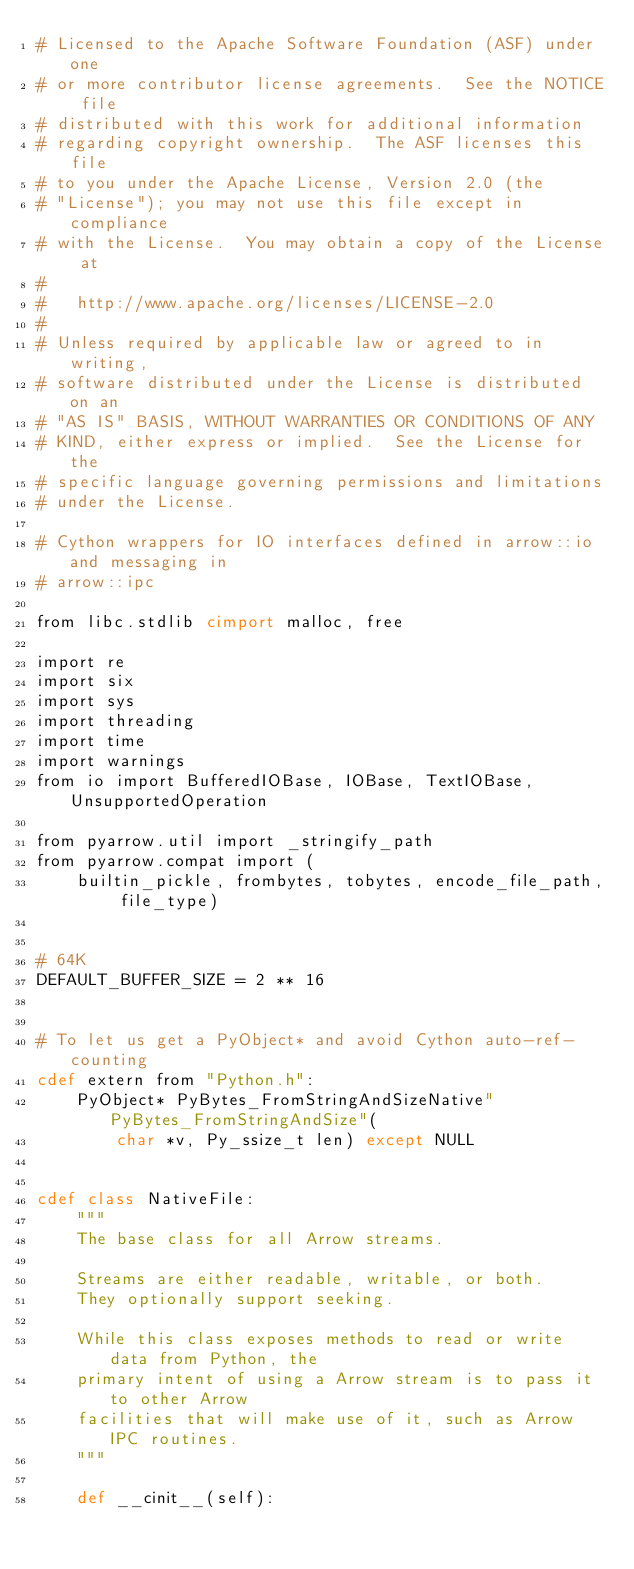Convert code to text. <code><loc_0><loc_0><loc_500><loc_500><_Cython_># Licensed to the Apache Software Foundation (ASF) under one
# or more contributor license agreements.  See the NOTICE file
# distributed with this work for additional information
# regarding copyright ownership.  The ASF licenses this file
# to you under the Apache License, Version 2.0 (the
# "License"); you may not use this file except in compliance
# with the License.  You may obtain a copy of the License at
#
#   http://www.apache.org/licenses/LICENSE-2.0
#
# Unless required by applicable law or agreed to in writing,
# software distributed under the License is distributed on an
# "AS IS" BASIS, WITHOUT WARRANTIES OR CONDITIONS OF ANY
# KIND, either express or implied.  See the License for the
# specific language governing permissions and limitations
# under the License.

# Cython wrappers for IO interfaces defined in arrow::io and messaging in
# arrow::ipc

from libc.stdlib cimport malloc, free

import re
import six
import sys
import threading
import time
import warnings
from io import BufferedIOBase, IOBase, TextIOBase, UnsupportedOperation

from pyarrow.util import _stringify_path
from pyarrow.compat import (
    builtin_pickle, frombytes, tobytes, encode_file_path, file_type)


# 64K
DEFAULT_BUFFER_SIZE = 2 ** 16


# To let us get a PyObject* and avoid Cython auto-ref-counting
cdef extern from "Python.h":
    PyObject* PyBytes_FromStringAndSizeNative" PyBytes_FromStringAndSize"(
        char *v, Py_ssize_t len) except NULL


cdef class NativeFile:
    """
    The base class for all Arrow streams.

    Streams are either readable, writable, or both.
    They optionally support seeking.

    While this class exposes methods to read or write data from Python, the
    primary intent of using a Arrow stream is to pass it to other Arrow
    facilities that will make use of it, such as Arrow IPC routines.
    """

    def __cinit__(self):</code> 